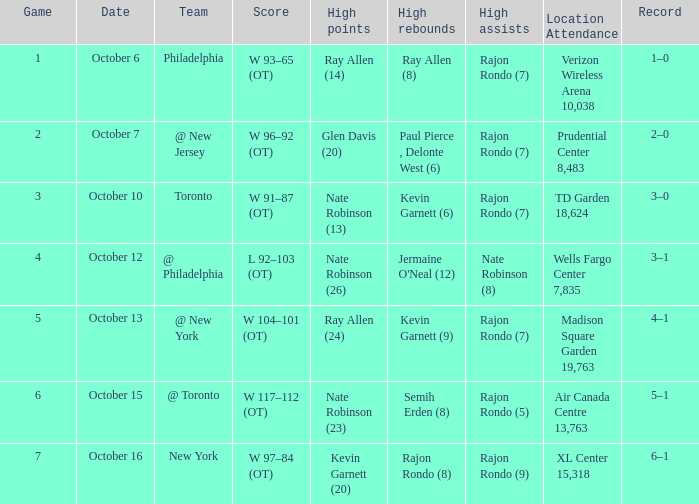Who secured the most assists, and how many were there on the 7th of october? Rajon Rondo (7). 